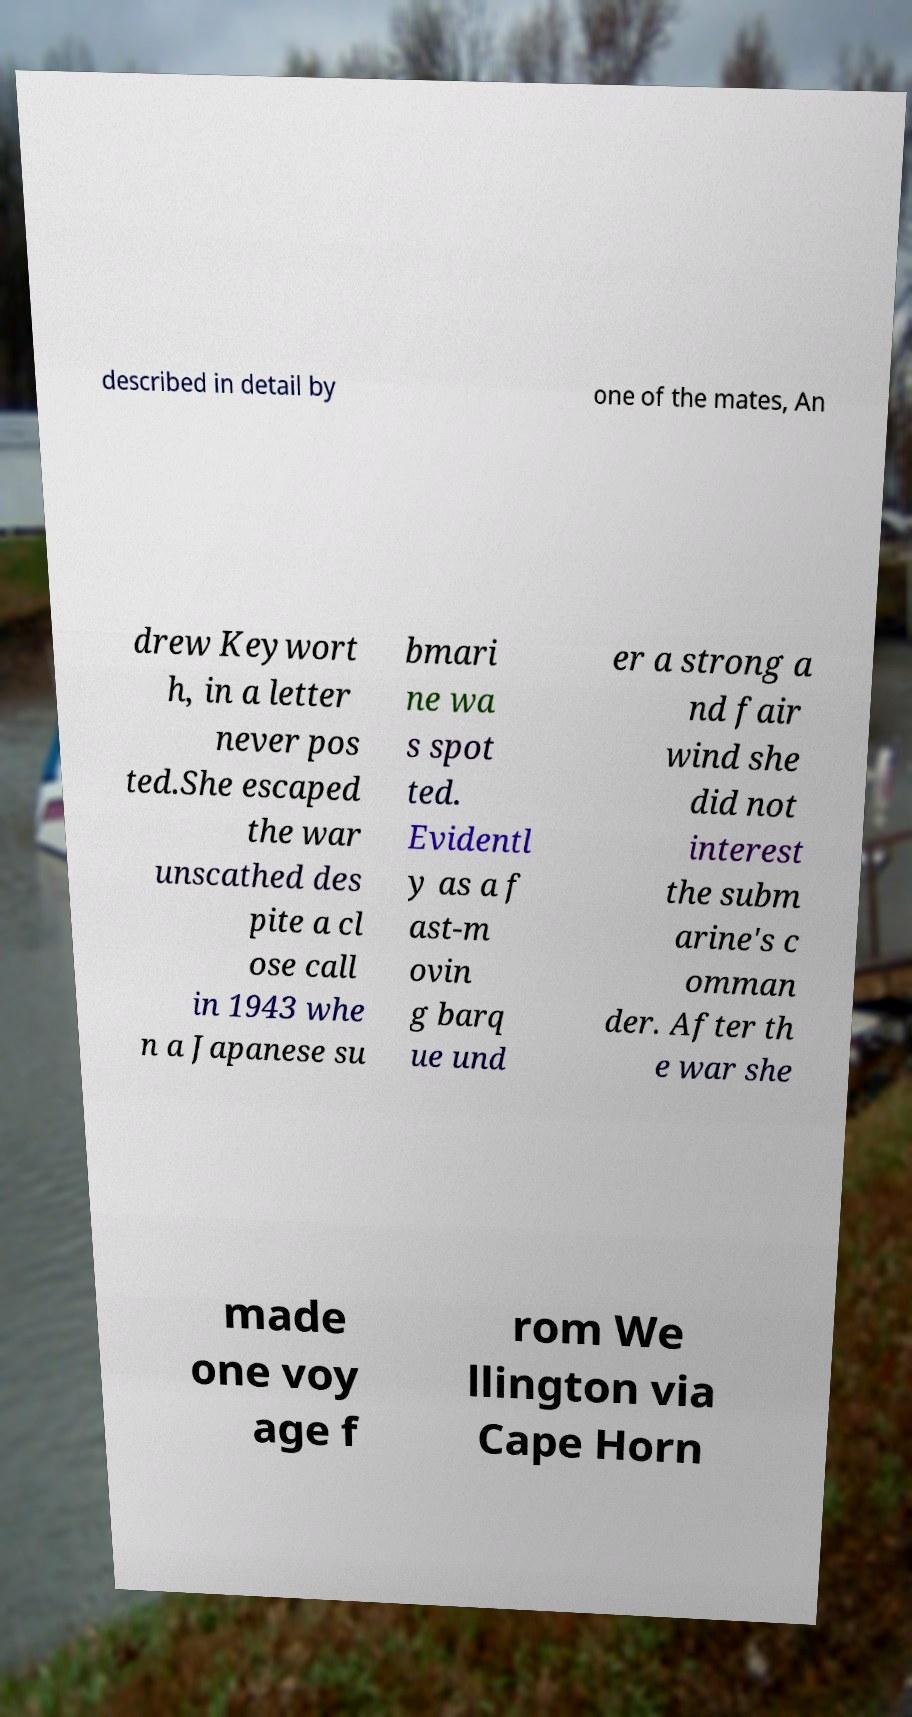Could you extract and type out the text from this image? described in detail by one of the mates, An drew Keywort h, in a letter never pos ted.She escaped the war unscathed des pite a cl ose call in 1943 whe n a Japanese su bmari ne wa s spot ted. Evidentl y as a f ast-m ovin g barq ue und er a strong a nd fair wind she did not interest the subm arine's c omman der. After th e war she made one voy age f rom We llington via Cape Horn 